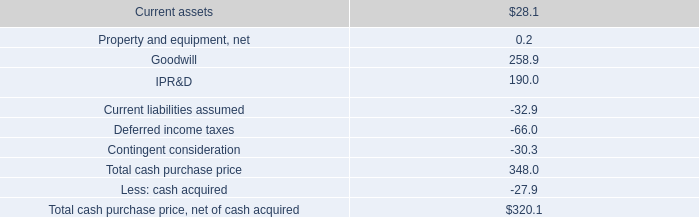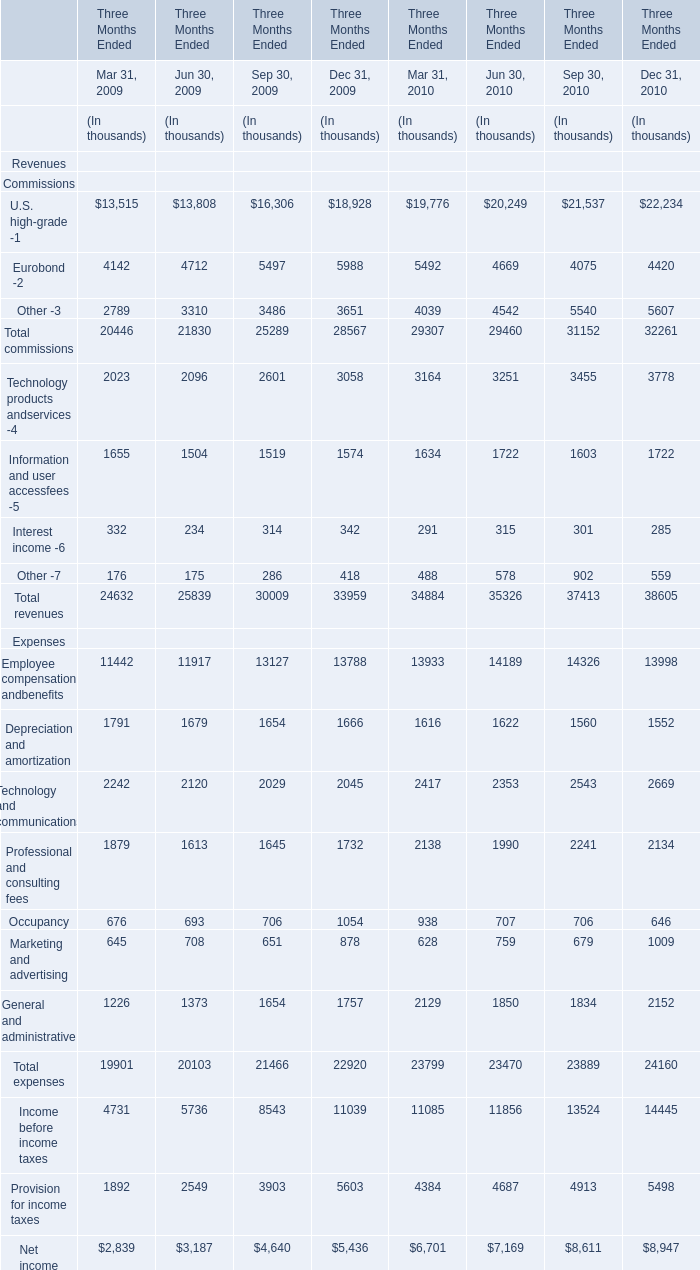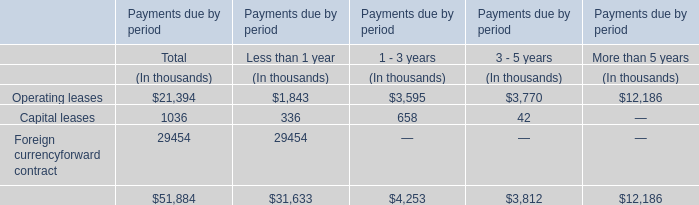In the section with largest amount of Eurobond -2, what's the sum of Other -3 and Total commissions ? (in thousand) 
Computations: (3651 + 28567)
Answer: 32218.0. 